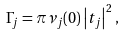Convert formula to latex. <formula><loc_0><loc_0><loc_500><loc_500>\Gamma _ { j } = \pi \nu _ { j } ( 0 ) \left | t _ { j } \right | ^ { 2 } ,</formula> 